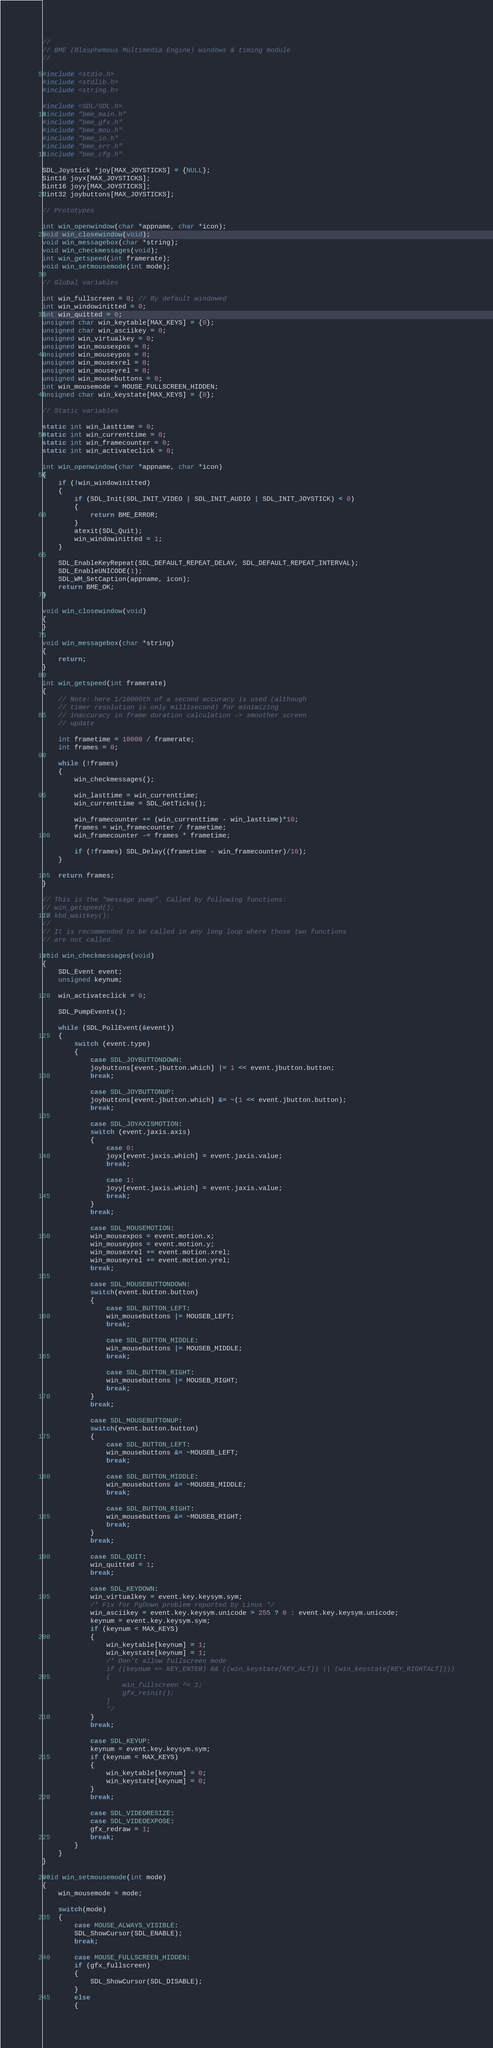Convert code to text. <code><loc_0><loc_0><loc_500><loc_500><_C_>//
// BME (Blasphemous Multimedia Engine) windows & timing module
//

#include <stdio.h>
#include <stdlib.h>
#include <string.h>

#include <SDL/SDL.h>
#include "bme_main.h"
#include "bme_gfx.h"
#include "bme_mou.h"
#include "bme_io.h"
#include "bme_err.h"
#include "bme_cfg.h"

SDL_Joystick *joy[MAX_JOYSTICKS] = {NULL};
Sint16 joyx[MAX_JOYSTICKS];
Sint16 joyy[MAX_JOYSTICKS];
Uint32 joybuttons[MAX_JOYSTICKS];

// Prototypes

int win_openwindow(char *appname, char *icon);
void win_closewindow(void);
void win_messagebox(char *string);
void win_checkmessages(void);
int win_getspeed(int framerate);
void win_setmousemode(int mode);

// Global variables

int win_fullscreen = 0; // By default windowed
int win_windowinitted = 0;
int win_quitted = 0;
unsigned char win_keytable[MAX_KEYS] = {0};
unsigned char win_asciikey = 0;
unsigned win_virtualkey = 0;
unsigned win_mousexpos = 0;
unsigned win_mouseypos = 0;
unsigned win_mousexrel = 0;
unsigned win_mouseyrel = 0;
unsigned win_mousebuttons = 0;
int win_mousemode = MOUSE_FULLSCREEN_HIDDEN;
unsigned char win_keystate[MAX_KEYS] = {0};

// Static variables

static int win_lasttime = 0;
static int win_currenttime = 0;
static int win_framecounter = 0;
static int win_activateclick = 0;

int win_openwindow(char *appname, char *icon)
{
    if (!win_windowinitted)
    {
        if (SDL_Init(SDL_INIT_VIDEO | SDL_INIT_AUDIO | SDL_INIT_JOYSTICK) < 0)
        {
            return BME_ERROR;
        }
        atexit(SDL_Quit);
        win_windowinitted = 1;
    }

    SDL_EnableKeyRepeat(SDL_DEFAULT_REPEAT_DELAY, SDL_DEFAULT_REPEAT_INTERVAL);
    SDL_EnableUNICODE(1);
    SDL_WM_SetCaption(appname, icon);
    return BME_OK;
}

void win_closewindow(void)
{
}

void win_messagebox(char *string)
{
    return;
}

int win_getspeed(int framerate)
{
    // Note: here 1/10000th of a second accuracy is used (although
    // timer resolution is only millisecond) for minimizing
    // inaccuracy in frame duration calculation -> smoother screen
    // update

    int frametime = 10000 / framerate;
    int frames = 0;

    while (!frames)
    {
        win_checkmessages();

        win_lasttime = win_currenttime;
        win_currenttime = SDL_GetTicks();

        win_framecounter += (win_currenttime - win_lasttime)*10;
        frames = win_framecounter / frametime;
        win_framecounter -= frames * frametime;

        if (!frames) SDL_Delay((frametime - win_framecounter)/10);
    }

    return frames;
}

// This is the "message pump". Called by following functions:
// win_getspeed();
// kbd_waitkey();
//
// It is recommended to be called in any long loop where those two functions
// are not called.

void win_checkmessages(void)
{
    SDL_Event event;
    unsigned keynum;

    win_activateclick = 0;

    SDL_PumpEvents();

    while (SDL_PollEvent(&event))
    {
        switch (event.type)
        {
            case SDL_JOYBUTTONDOWN:
            joybuttons[event.jbutton.which] |= 1 << event.jbutton.button;
            break;

            case SDL_JOYBUTTONUP:
            joybuttons[event.jbutton.which] &= ~(1 << event.jbutton.button);
            break;

            case SDL_JOYAXISMOTION:
            switch (event.jaxis.axis)
            {
                case 0:
                joyx[event.jaxis.which] = event.jaxis.value;
                break;

                case 1:
                joyy[event.jaxis.which] = event.jaxis.value;
                break;
            }
            break;

            case SDL_MOUSEMOTION:
            win_mousexpos = event.motion.x;
            win_mouseypos = event.motion.y;
            win_mousexrel += event.motion.xrel;
            win_mouseyrel += event.motion.yrel;
            break;

            case SDL_MOUSEBUTTONDOWN:
            switch(event.button.button)
            {
                case SDL_BUTTON_LEFT:
                win_mousebuttons |= MOUSEB_LEFT;
                break;

                case SDL_BUTTON_MIDDLE:
                win_mousebuttons |= MOUSEB_MIDDLE;
                break;

                case SDL_BUTTON_RIGHT:
                win_mousebuttons |= MOUSEB_RIGHT;
                break;
            }
            break;

            case SDL_MOUSEBUTTONUP:
            switch(event.button.button)
            {
                case SDL_BUTTON_LEFT:
                win_mousebuttons &= ~MOUSEB_LEFT;
                break;

                case SDL_BUTTON_MIDDLE:
                win_mousebuttons &= ~MOUSEB_MIDDLE;
                break;

                case SDL_BUTTON_RIGHT:
                win_mousebuttons &= ~MOUSEB_RIGHT;
                break;
            }
            break;

            case SDL_QUIT:
            win_quitted = 1;
            break;

            case SDL_KEYDOWN:
            win_virtualkey = event.key.keysym.sym;
            /* Fix for PgDown problem reported by Linus */
            win_asciikey = event.key.keysym.unicode > 255 ? 0 : event.key.keysym.unicode;
            keynum = event.key.keysym.sym;
            if (keynum < MAX_KEYS)
            {
                win_keytable[keynum] = 1;
                win_keystate[keynum] = 1;
				/* Don't allow fullscreen mode
                if ((keynum == KEY_ENTER) && ((win_keystate[KEY_ALT]) || (win_keystate[KEY_RIGHTALT])))
                {
                    win_fullscreen ^= 1;
                    gfx_reinit();
                }
				*/ 
            }
            break;

            case SDL_KEYUP:
            keynum = event.key.keysym.sym;
            if (keynum < MAX_KEYS)
            {
                win_keytable[keynum] = 0;
                win_keystate[keynum] = 0;
            }
            break;

            case SDL_VIDEORESIZE:
            case SDL_VIDEOEXPOSE:
            gfx_redraw = 1;
            break;
        }
    }
}

void win_setmousemode(int mode)
{
    win_mousemode = mode;

    switch(mode)
    {
        case MOUSE_ALWAYS_VISIBLE:
        SDL_ShowCursor(SDL_ENABLE);
        break;

        case MOUSE_FULLSCREEN_HIDDEN:
        if (gfx_fullscreen)
        {
            SDL_ShowCursor(SDL_DISABLE);
        }
        else
        {</code> 